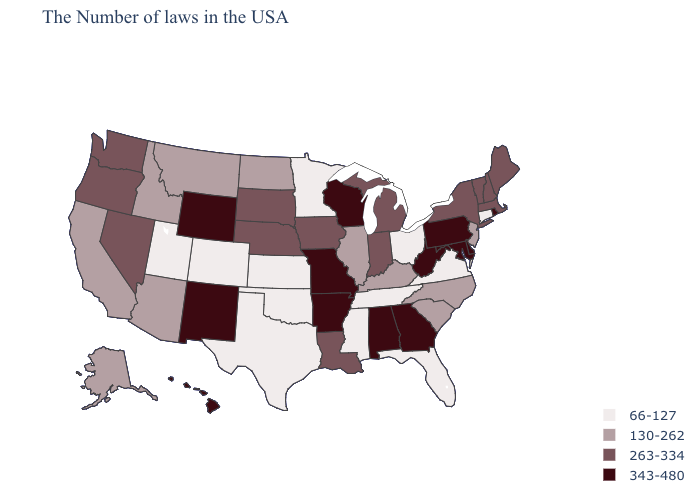Is the legend a continuous bar?
Write a very short answer. No. What is the highest value in the MidWest ?
Write a very short answer. 343-480. Name the states that have a value in the range 343-480?
Short answer required. Rhode Island, Delaware, Maryland, Pennsylvania, West Virginia, Georgia, Alabama, Wisconsin, Missouri, Arkansas, Wyoming, New Mexico, Hawaii. Name the states that have a value in the range 263-334?
Answer briefly. Maine, Massachusetts, New Hampshire, Vermont, New York, Michigan, Indiana, Louisiana, Iowa, Nebraska, South Dakota, Nevada, Washington, Oregon. Which states have the lowest value in the USA?
Write a very short answer. Connecticut, Virginia, Ohio, Florida, Tennessee, Mississippi, Minnesota, Kansas, Oklahoma, Texas, Colorado, Utah. Name the states that have a value in the range 343-480?
Short answer required. Rhode Island, Delaware, Maryland, Pennsylvania, West Virginia, Georgia, Alabama, Wisconsin, Missouri, Arkansas, Wyoming, New Mexico, Hawaii. What is the value of Utah?
Answer briefly. 66-127. Which states have the lowest value in the USA?
Answer briefly. Connecticut, Virginia, Ohio, Florida, Tennessee, Mississippi, Minnesota, Kansas, Oklahoma, Texas, Colorado, Utah. Which states have the lowest value in the West?
Answer briefly. Colorado, Utah. Which states have the lowest value in the USA?
Give a very brief answer. Connecticut, Virginia, Ohio, Florida, Tennessee, Mississippi, Minnesota, Kansas, Oklahoma, Texas, Colorado, Utah. Which states have the lowest value in the USA?
Write a very short answer. Connecticut, Virginia, Ohio, Florida, Tennessee, Mississippi, Minnesota, Kansas, Oklahoma, Texas, Colorado, Utah. Does Hawaii have the same value as New York?
Keep it brief. No. Name the states that have a value in the range 343-480?
Short answer required. Rhode Island, Delaware, Maryland, Pennsylvania, West Virginia, Georgia, Alabama, Wisconsin, Missouri, Arkansas, Wyoming, New Mexico, Hawaii. What is the value of Virginia?
Concise answer only. 66-127. What is the value of Washington?
Answer briefly. 263-334. 